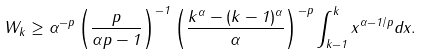Convert formula to latex. <formula><loc_0><loc_0><loc_500><loc_500>W _ { k } \geq \alpha ^ { - p } \left ( \frac { p } { \alpha p - 1 } \right ) ^ { - 1 } \left ( \frac { k ^ { \alpha } - ( k - 1 ) ^ { \alpha } } { \alpha } \right ) ^ { - p } \int ^ { k } _ { k - 1 } x ^ { \alpha - 1 / p } d x .</formula> 